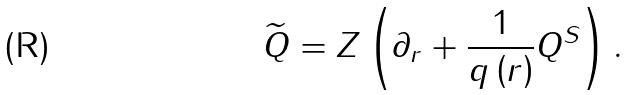<formula> <loc_0><loc_0><loc_500><loc_500>\widetilde { Q } = Z \left ( \partial _ { r } + \frac { 1 } { q \left ( r \right ) } Q ^ { S } \right ) .</formula> 